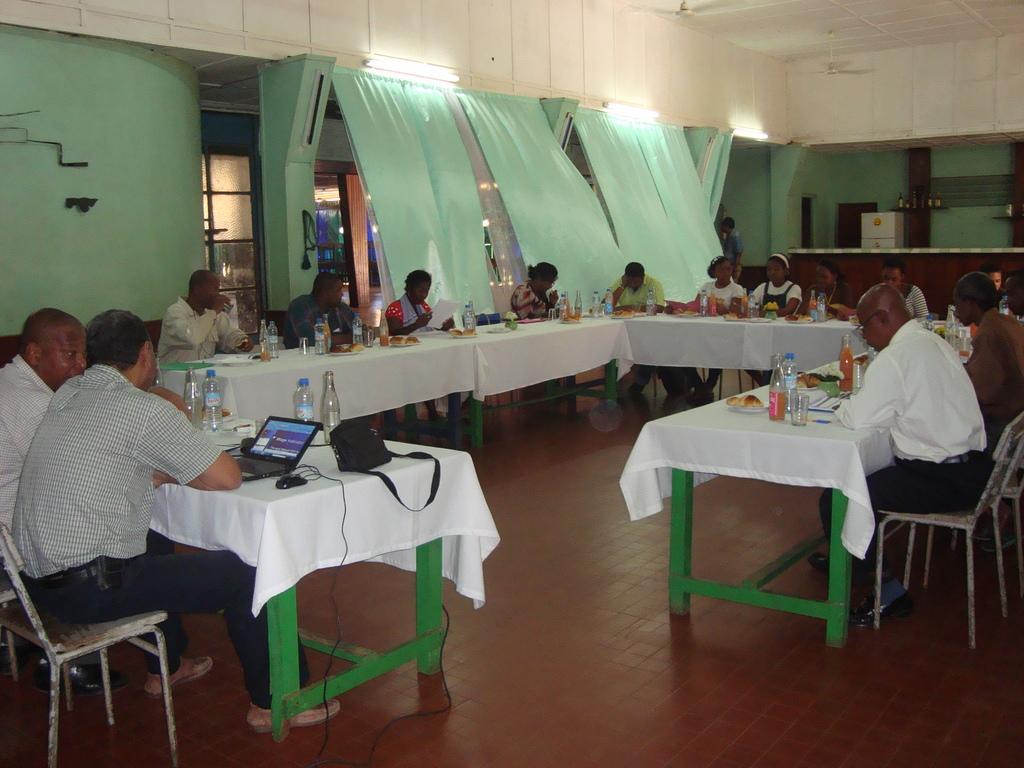In one or two sentences, can you explain what this image depicts? This is a floor. Here we can see all the persons sitting on chairs in front of a table and on the table we can see white cloth, a plate of food, glasses, water bottles, laptop, mouse and a bag. These are curtains. These are tube lights. This is a ceiling and fans. 